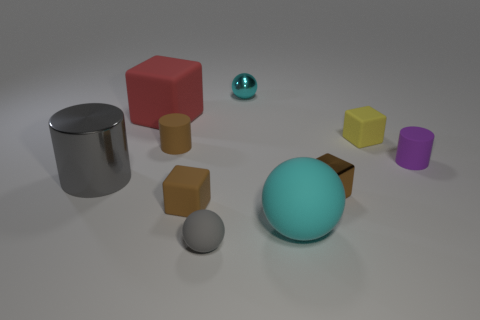What number of tiny green rubber balls are there?
Ensure brevity in your answer.  0. What material is the sphere behind the matte thing right of the yellow rubber object made of?
Your answer should be compact. Metal. There is a large cube that is the same material as the tiny gray ball; what color is it?
Offer a terse response. Red. There is a big matte object that is the same color as the metallic ball; what shape is it?
Provide a short and direct response. Sphere. There is a cyan ball that is in front of the tiny yellow object; is it the same size as the cyan object that is behind the big gray shiny object?
Offer a very short reply. No. What number of spheres are either large shiny objects or red rubber things?
Your response must be concise. 0. Are the cyan ball that is behind the red matte thing and the brown cylinder made of the same material?
Offer a very short reply. No. How many other things are the same size as the brown matte cylinder?
Offer a terse response. 6. What number of large things are brown blocks or blue rubber spheres?
Offer a terse response. 0. Is the color of the small metallic sphere the same as the shiny cylinder?
Offer a terse response. No. 